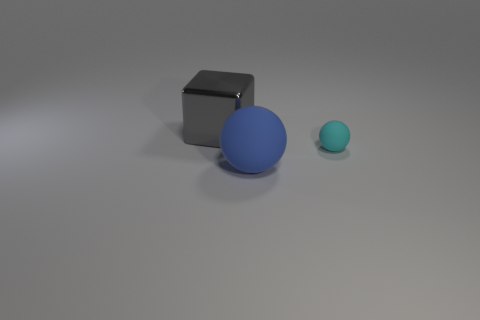Is there any other thing that has the same material as the big gray thing?
Make the answer very short. No. Is the number of spheres that are right of the big ball greater than the number of small gray blocks?
Ensure brevity in your answer.  Yes. There is a metal thing; does it have the same shape as the big thing that is to the right of the gray metal thing?
Provide a succinct answer. No. How many blue balls are the same size as the gray shiny block?
Provide a short and direct response. 1. How many blue matte balls are left of the rubber ball that is behind the big thing right of the gray shiny block?
Keep it short and to the point. 1. Is the number of small cyan matte objects that are behind the large block the same as the number of cubes that are in front of the blue object?
Provide a succinct answer. Yes. How many cyan matte objects are the same shape as the blue object?
Provide a short and direct response. 1. Is there a cube that has the same material as the tiny ball?
Offer a terse response. No. What number of spheres are there?
Offer a very short reply. 2. How many blocks are either tiny cyan matte things or small gray metal objects?
Keep it short and to the point. 0. 